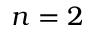Convert formula to latex. <formula><loc_0><loc_0><loc_500><loc_500>n = 2</formula> 